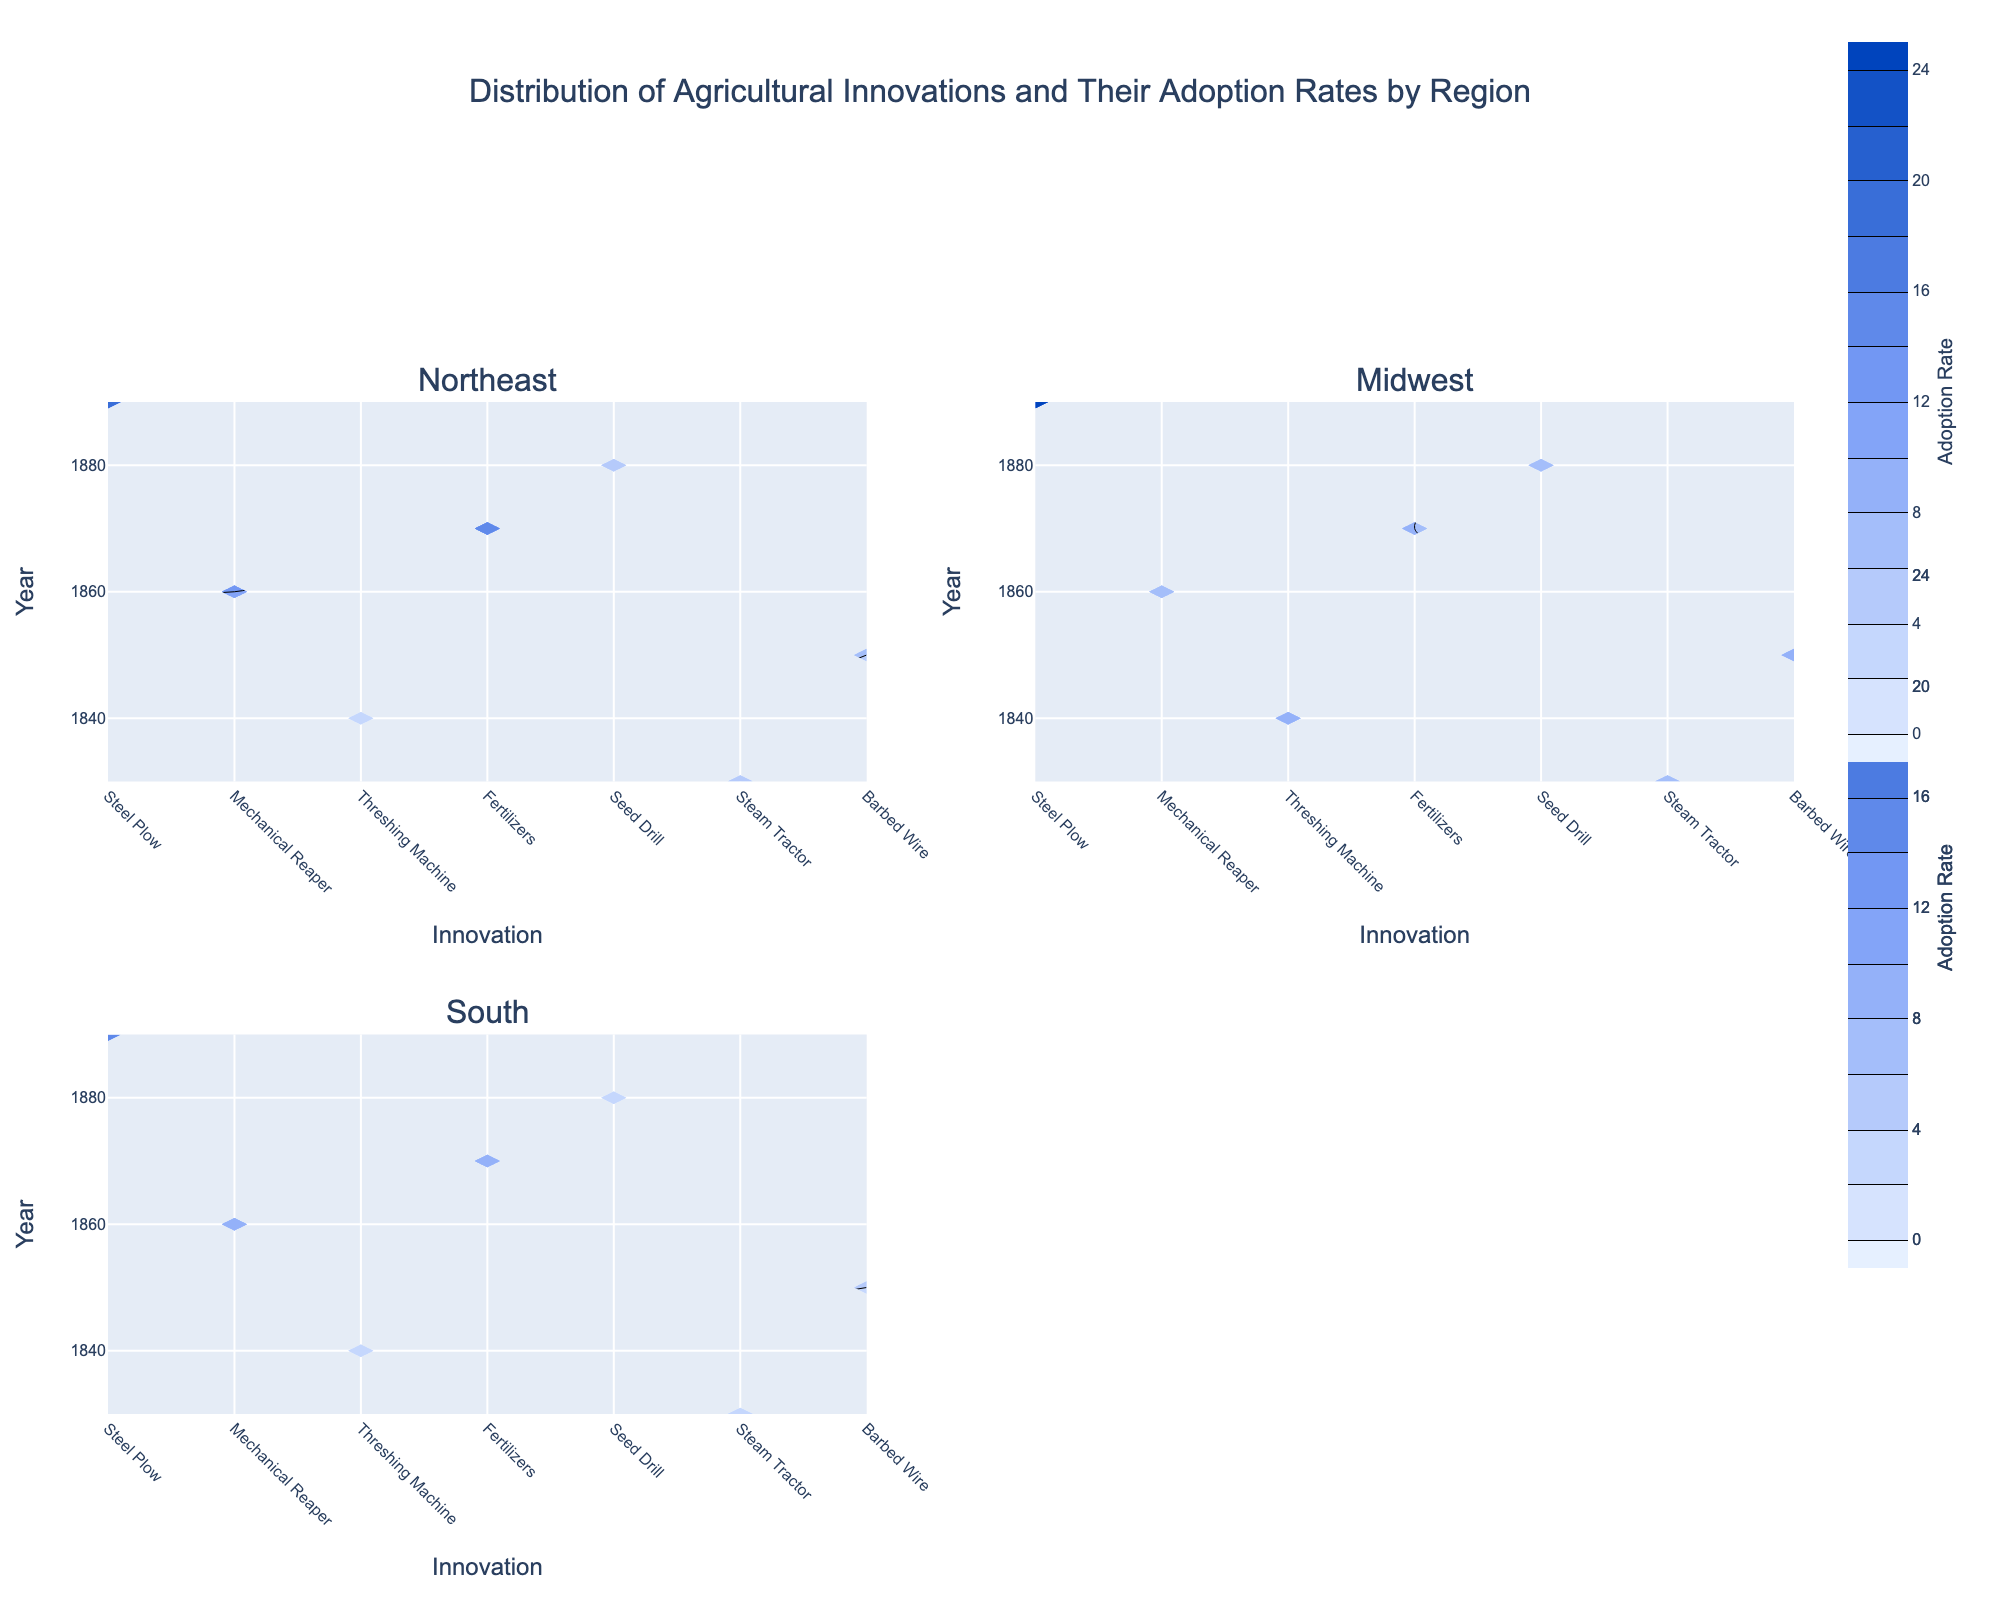What's the title of the figure? The title is stated at the top of the figure and gives an overview of the content. The words are generally larger and bolded to differentiate them from other text.
Answer: Distribution of Agricultural Innovations and Their Adoption Rates by Region What is the color scale used in the contour plots? The color scale is indicated by the colors filling the contours in the plot. The legend on the right-hand side shows a gradient from light to dark shades.
Answer: Light blue to dark blue Which region had the highest adoption rate for the Steel Plow in 1830? To find this, look at the contours for the year 1830 and the innovation Steel Plow across different regions. Find the region with the contour marking the highest rate.
Answer: Midwest What's the adoption rate of Barbed Wire in the Northeast region in 1890? Locate the Northeast region's subplot, then find 1890 on the y-axis and Barbed Wire on the x-axis. Identify the adoption rate by observing the corresponding contour value.
Answer: 20 How does the adoption rate of the Mechanical Reaper in the Midwest in 1840 compare to the South in the same year? Look at the contour values for the Mechanical Reaper in 1840 for both regions. Compare the values to determine which is higher.
Answer: Midwest is higher In which region and for which innovation was the lowest adoption rate observed in 1880? Check the 1880 contours across all subplots for each innovation, identify the lowest value, and note which region and innovation it corresponds to.
Answer: South, Steam Tractor What was the trend in the adoption rate of Fertilizers from 1860 to 1870 in the Northeast? Review the contour for Fertilizers in the Northeast subplot and examine how the contour values change from 1860 to 1870. Check if they increase, decrease, or stay constant.
Answer: Increase Which innovation had the highest adoption rate in the South in 1890 and how much was it? Locate the South region's subplot, find 1890 on the y-axis, and compare adoption rates for all innovations. Identify the innovation with the highest contour value.
Answer: Barbed Wire, 15 Comparing Seed Drill adoption rates in 1870, which region saw the lowest rate? Look at the Seed Drill innovation and find the 1870 contour values across all regions. Identify the region with the lowest value.
Answer: Midwest What is the general trend in innovation adoption in the Northeast from 1830 to 1890? Examine the contours for all innovations in the Northeast subplot over the years. Summarize the trend by noting if adoption rates generally increase, decrease, or show any specific patterns.
Answer: Increasing trend 